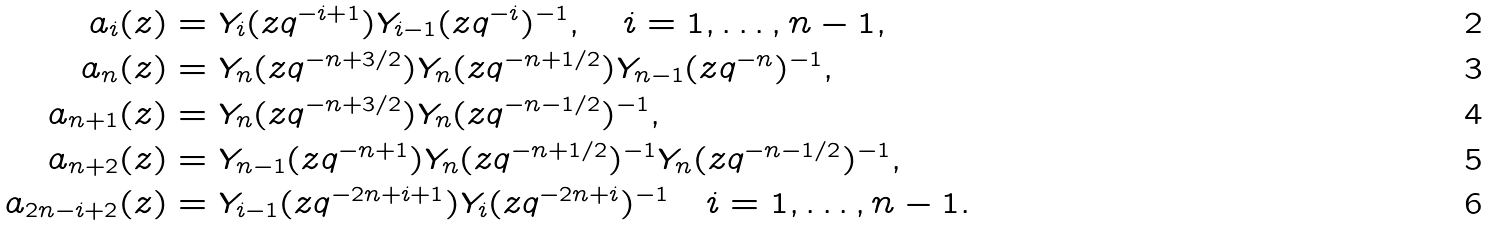<formula> <loc_0><loc_0><loc_500><loc_500>\L a _ { i } ( z ) & = Y _ { i } ( z q ^ { - i + 1 } ) Y _ { i - 1 } ( z q ^ { - i } ) ^ { - 1 } , \quad i = 1 , \dots , n - 1 , \\ \L a _ { n } ( z ) & = Y _ { n } ( z q ^ { - n + 3 / 2 } ) Y _ { n } ( z q ^ { - n + 1 / 2 } ) Y _ { n - 1 } ( z q ^ { - n } ) ^ { - 1 } , \\ \L a _ { n + 1 } ( z ) & = Y _ { n } ( z q ^ { - n + 3 / 2 } ) Y _ { n } ( z q ^ { - n - 1 / 2 } ) ^ { - 1 } , \\ \L a _ { n + 2 } ( z ) & = Y _ { n - 1 } ( z q ^ { - n + 1 } ) Y _ { n } ( z q ^ { - n + 1 / 2 } ) ^ { - 1 } Y _ { n } ( z q ^ { - n - 1 / 2 } ) ^ { - 1 } , \\ \L a _ { 2 n - i + 2 } ( z ) & = Y _ { i - 1 } ( z q ^ { - 2 n + i + 1 } ) Y _ { i } ( z q ^ { - 2 n + i } ) ^ { - 1 } \quad i = 1 , \dots , n - 1 .</formula> 